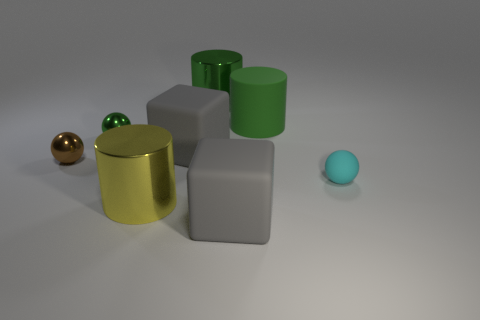Add 1 brown objects. How many objects exist? 9 Subtract all spheres. How many objects are left? 5 Add 3 big cylinders. How many big cylinders exist? 6 Subtract 0 brown cubes. How many objects are left? 8 Subtract all purple rubber cylinders. Subtract all tiny green metal spheres. How many objects are left? 7 Add 4 green metallic cylinders. How many green metallic cylinders are left? 5 